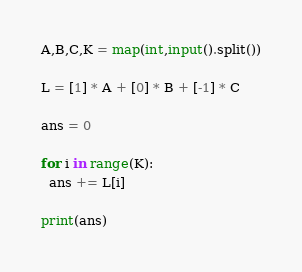<code> <loc_0><loc_0><loc_500><loc_500><_Python_>A,B,C,K = map(int,input().split())

L = [1] * A + [0] * B + [-1] * C

ans = 0

for i in range(K):
  ans += L[i]
  
print(ans)</code> 